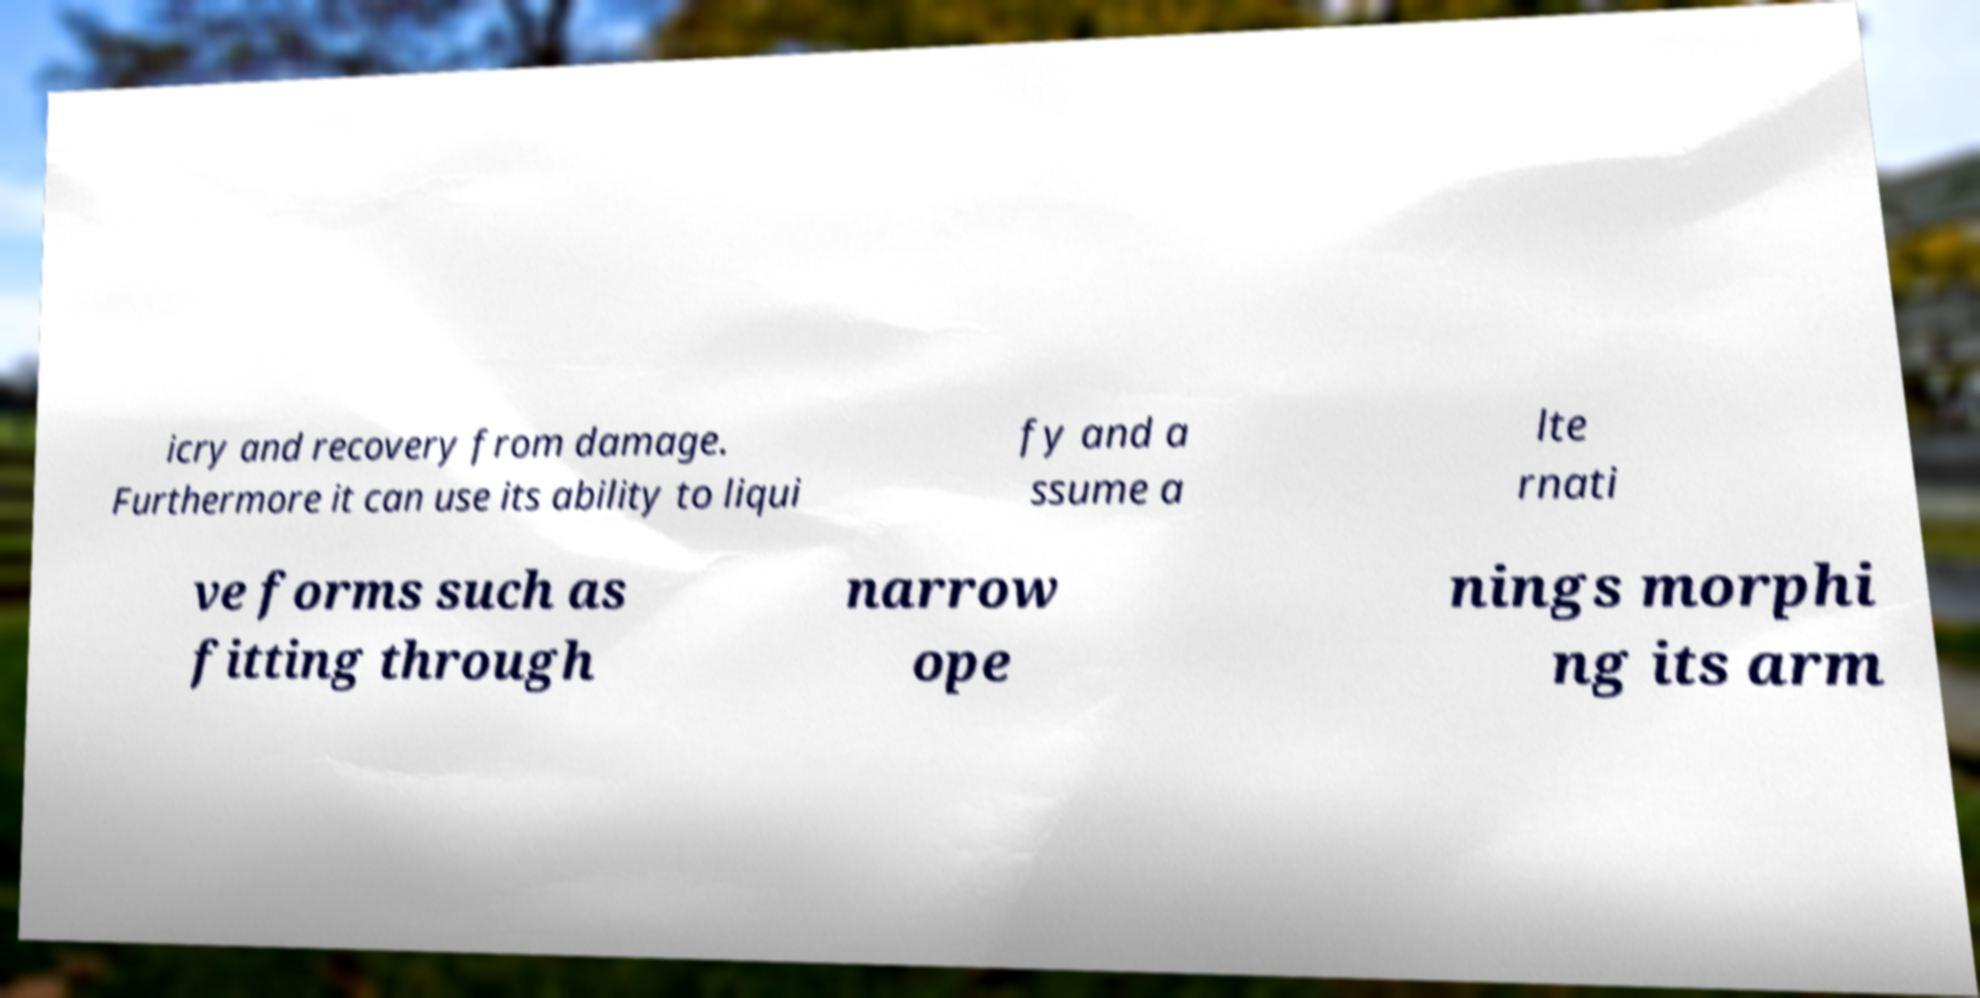Please read and relay the text visible in this image. What does it say? icry and recovery from damage. Furthermore it can use its ability to liqui fy and a ssume a lte rnati ve forms such as fitting through narrow ope nings morphi ng its arm 